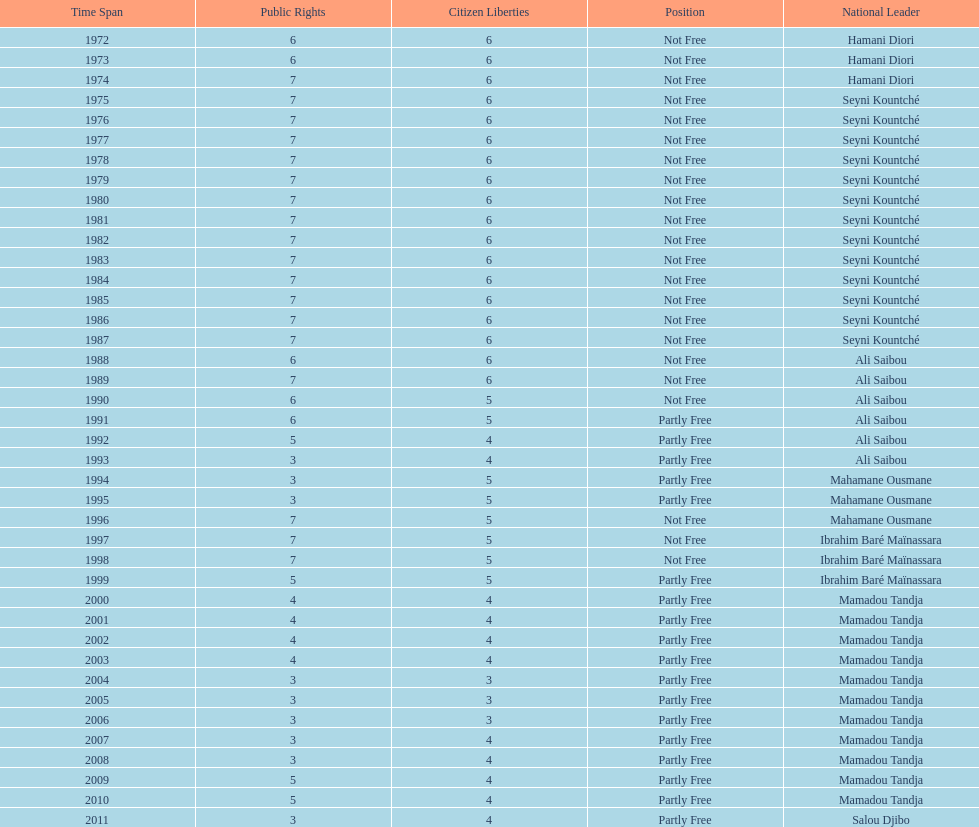How many occurrences involved the political rights being cited as seven? 18. 